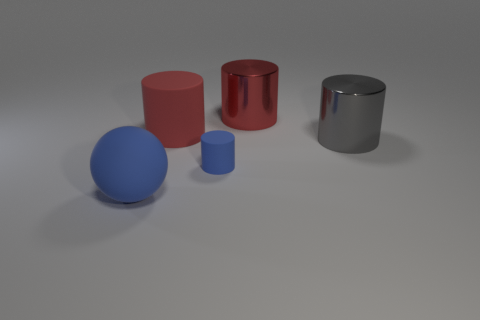Add 4 small yellow rubber objects. How many objects exist? 9 Subtract all cyan cylinders. Subtract all yellow spheres. How many cylinders are left? 4 Subtract all cylinders. How many objects are left? 1 Subtract 0 red spheres. How many objects are left? 5 Subtract all small red blocks. Subtract all tiny objects. How many objects are left? 4 Add 5 red rubber cylinders. How many red rubber cylinders are left? 6 Add 1 metallic things. How many metallic things exist? 3 